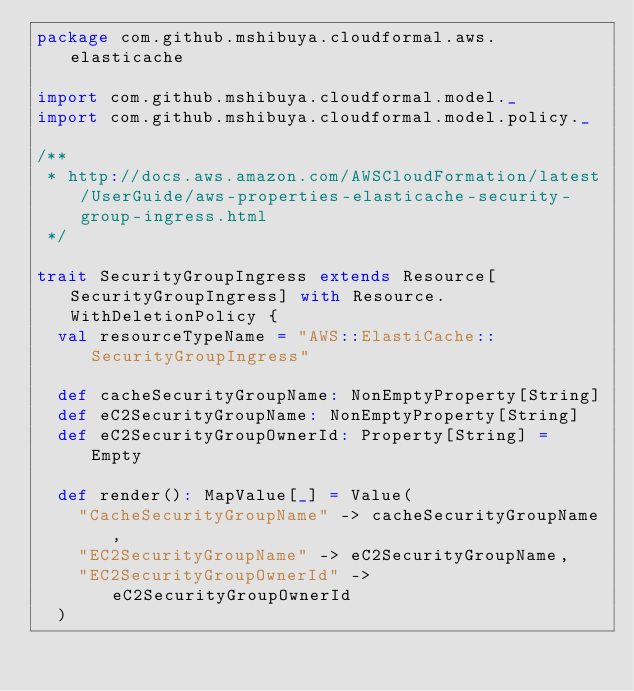<code> <loc_0><loc_0><loc_500><loc_500><_Scala_>package com.github.mshibuya.cloudformal.aws.elasticache

import com.github.mshibuya.cloudformal.model._
import com.github.mshibuya.cloudformal.model.policy._

/**
 * http://docs.aws.amazon.com/AWSCloudFormation/latest/UserGuide/aws-properties-elasticache-security-group-ingress.html
 */

trait SecurityGroupIngress extends Resource[SecurityGroupIngress] with Resource.WithDeletionPolicy {
  val resourceTypeName = "AWS::ElastiCache::SecurityGroupIngress"

  def cacheSecurityGroupName: NonEmptyProperty[String]
  def eC2SecurityGroupName: NonEmptyProperty[String]
  def eC2SecurityGroupOwnerId: Property[String] = Empty

  def render(): MapValue[_] = Value(
    "CacheSecurityGroupName" -> cacheSecurityGroupName,
    "EC2SecurityGroupName" -> eC2SecurityGroupName,
    "EC2SecurityGroupOwnerId" -> eC2SecurityGroupOwnerId
  )</code> 